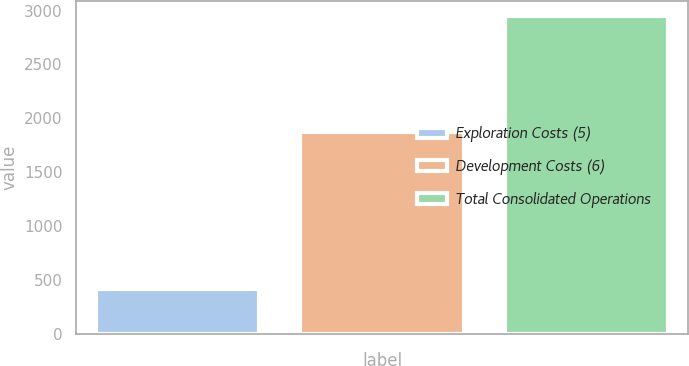Convert chart to OTSL. <chart><loc_0><loc_0><loc_500><loc_500><bar_chart><fcel>Exploration Costs (5)<fcel>Development Costs (6)<fcel>Total Consolidated Operations<nl><fcel>418<fcel>1871<fcel>2946<nl></chart> 